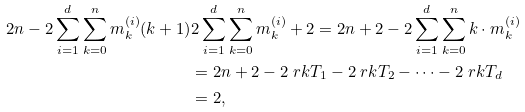Convert formula to latex. <formula><loc_0><loc_0><loc_500><loc_500>2 n - 2 \sum _ { i = 1 } ^ { d } \sum _ { k = 0 } ^ { n } m ^ { ( i ) } _ { k } ( k + 1 ) & 2 \sum _ { i = 1 } ^ { d } \sum _ { k = 0 } ^ { n } m ^ { ( i ) } _ { k } + 2 = 2 n + 2 - 2 \sum _ { i = 1 } ^ { d } \sum _ { k = 0 } ^ { n } k \cdot m ^ { ( i ) } _ { k } \\ & = 2 n + 2 - 2 \ r k T _ { 1 } - 2 \ r k T _ { 2 } - \dots - 2 \ r k T _ { d } \\ & = 2 ,</formula> 